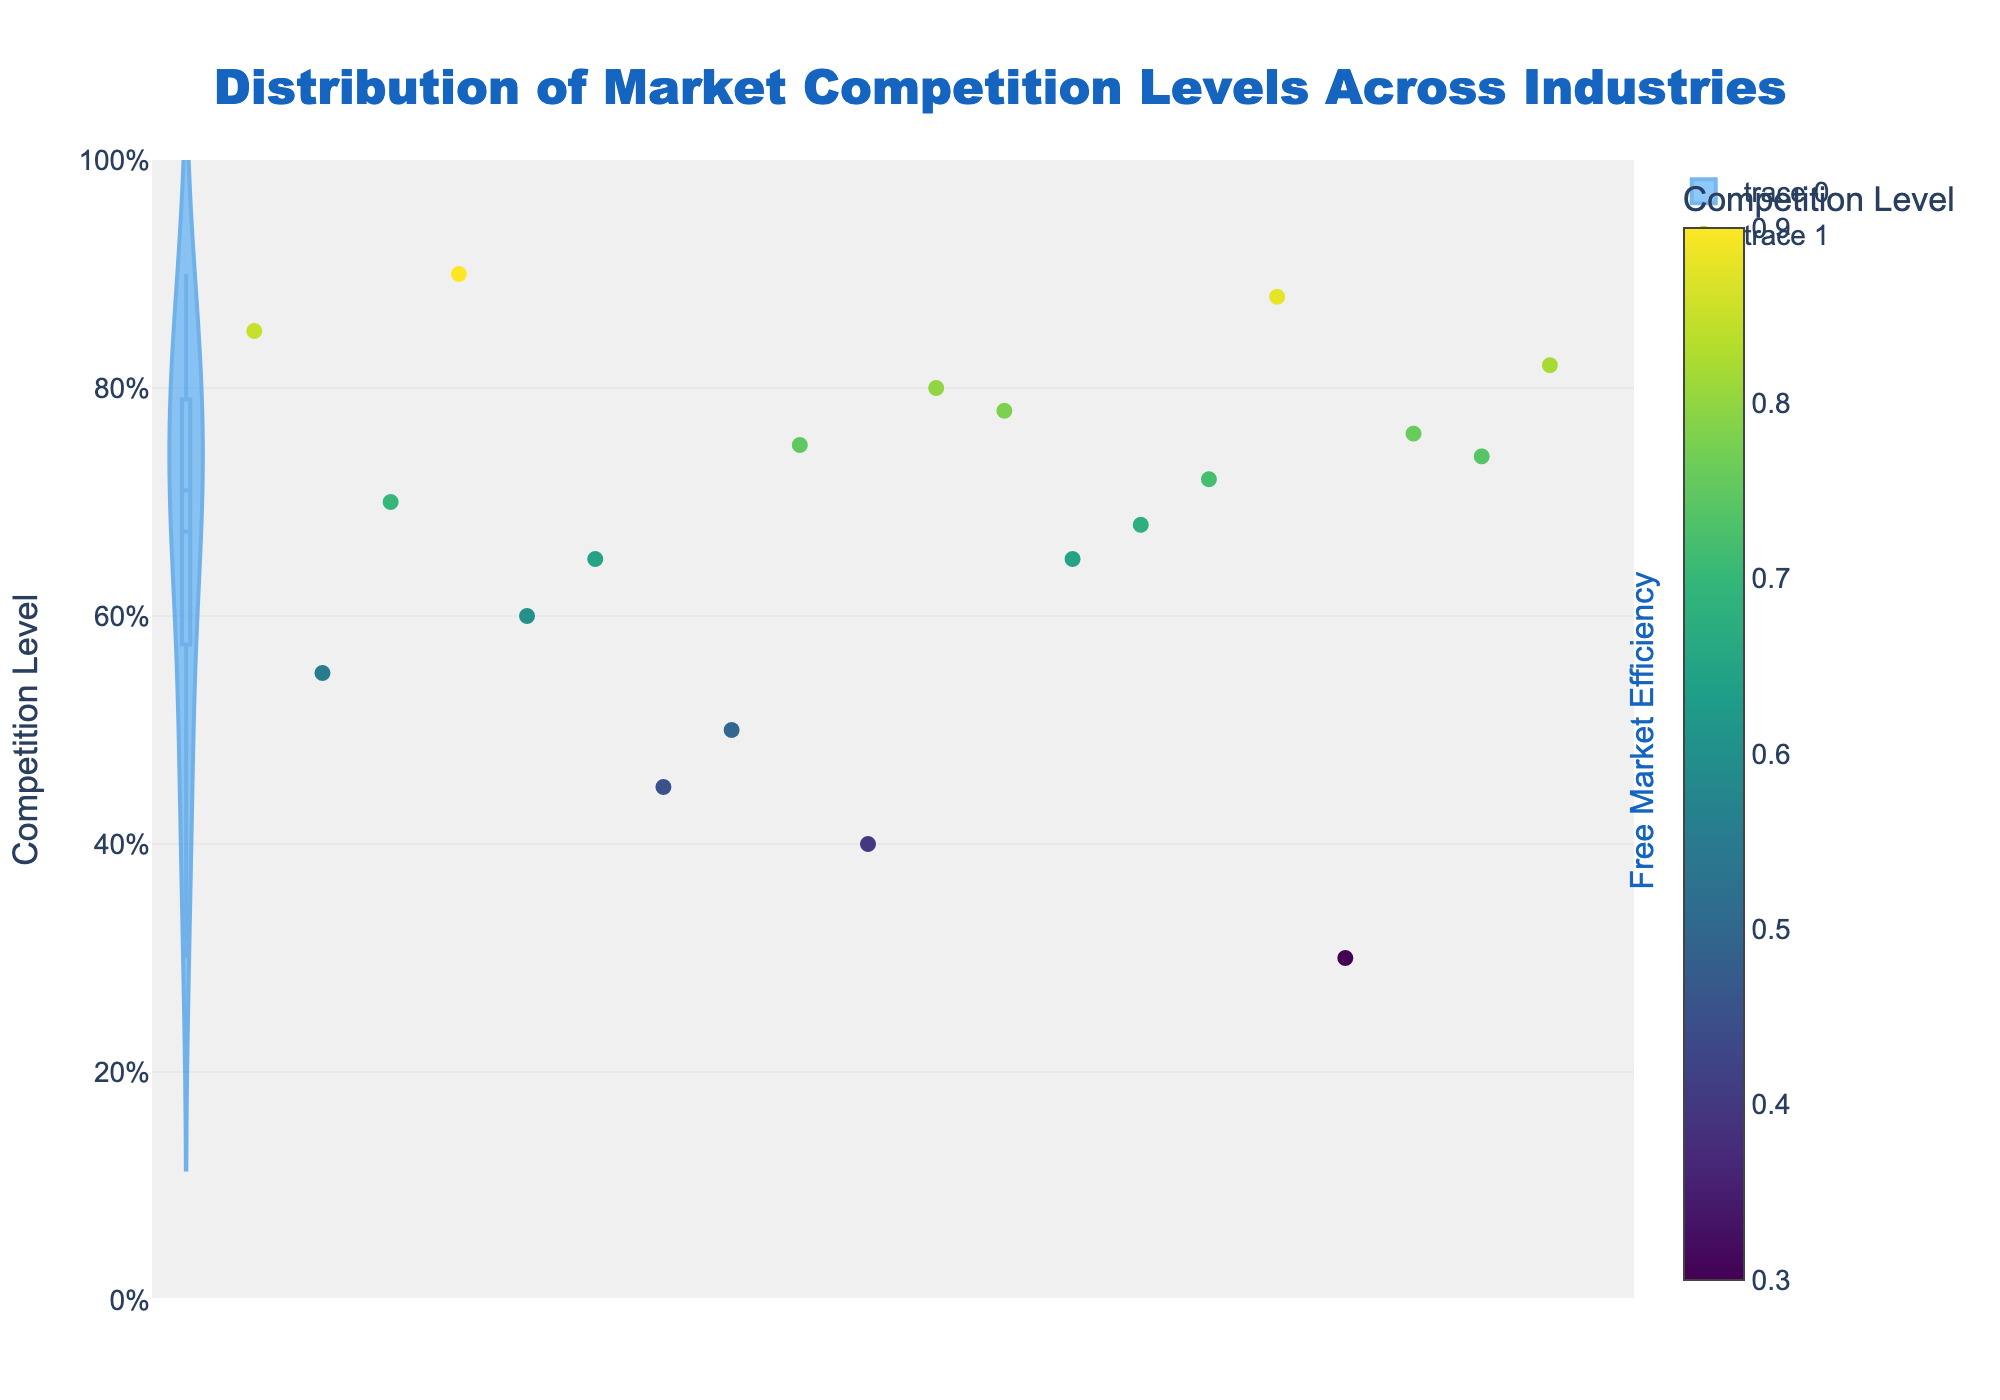What's the title of the figure? The title of the figure can be seen at the top of the plot. It is usually larger and more prominent than other text elements.
Answer: Distribution of Market Competition Levels Across Industries What does the x-axis represent in this figure? The x-axis label indicates what it represents. In this figure, it is labeled with 'Industry'.
Answer: Industry What does the y-axis represent in this figure? The y-axis label indicates what it represents. In this figure, it is labeled with 'Competition Level'.
Answer: Competition Level Which industry has the highest competition level? By looking at the scatter plot, identify the industry with the highest y-value (closest to 1.0).
Answer: Retail Which industry has the lowest competition level? By looking at the scatter plot, identify the industry with the lowest y-value (closest to 0.0).
Answer: Utilities What is the average competition level across all industries? This requires calculating the average of all the competition levels provided. Summing all levels and then dividing by the number of industries (20). The exact computation isn't visible but visual reference suggests around 0.67.
Answer: Approximately 0.67 How many industries have a competition level greater than 0.75? Locate the points in the scatter plot that have y-values greater than 0.75 and count them.
Answer: 7 industries What is the range of the competition levels present in the plot? The range is determined by the minimum and maximum values on the y-axis, which are 0.30 and 0.90 respectively for this plot.
Answer: 0.60 Which industry shows particularly high contrast in competition level with Pharmaceuticals? Identify Pharmaceuticals on the scatter plot and compare it with other industries, looking for one with a vastly different y-value.
Answer: Retail 